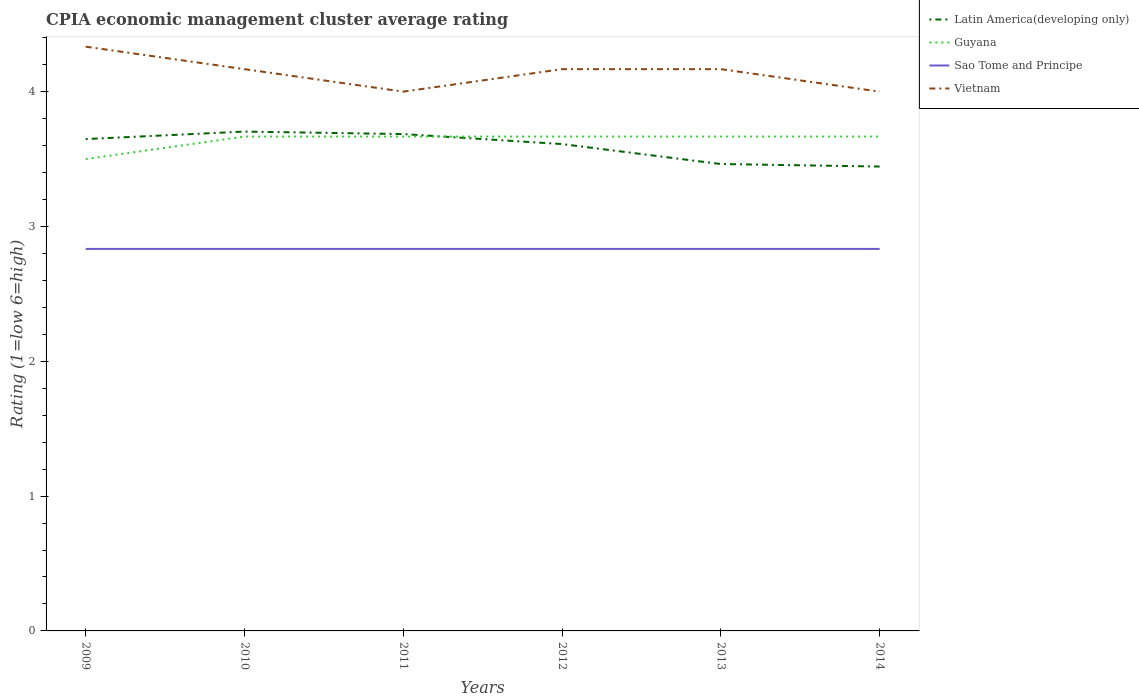What is the total CPIA rating in Guyana in the graph?
Your response must be concise. -3.333333329802457e-6. What is the difference between the highest and the second highest CPIA rating in Latin America(developing only)?
Ensure brevity in your answer.  0.26. What is the difference between the highest and the lowest CPIA rating in Vietnam?
Offer a very short reply. 4. Is the CPIA rating in Vietnam strictly greater than the CPIA rating in Sao Tome and Principe over the years?
Provide a succinct answer. No. How many years are there in the graph?
Your answer should be compact. 6. Does the graph contain any zero values?
Your answer should be compact. No. What is the title of the graph?
Provide a short and direct response. CPIA economic management cluster average rating. Does "China" appear as one of the legend labels in the graph?
Provide a short and direct response. No. What is the label or title of the X-axis?
Give a very brief answer. Years. What is the Rating (1=low 6=high) of Latin America(developing only) in 2009?
Your answer should be compact. 3.65. What is the Rating (1=low 6=high) in Sao Tome and Principe in 2009?
Offer a very short reply. 2.83. What is the Rating (1=low 6=high) of Vietnam in 2009?
Provide a succinct answer. 4.33. What is the Rating (1=low 6=high) in Latin America(developing only) in 2010?
Keep it short and to the point. 3.7. What is the Rating (1=low 6=high) of Guyana in 2010?
Offer a very short reply. 3.67. What is the Rating (1=low 6=high) in Sao Tome and Principe in 2010?
Offer a terse response. 2.83. What is the Rating (1=low 6=high) in Vietnam in 2010?
Provide a succinct answer. 4.17. What is the Rating (1=low 6=high) of Latin America(developing only) in 2011?
Provide a succinct answer. 3.69. What is the Rating (1=low 6=high) in Guyana in 2011?
Your response must be concise. 3.67. What is the Rating (1=low 6=high) in Sao Tome and Principe in 2011?
Make the answer very short. 2.83. What is the Rating (1=low 6=high) in Vietnam in 2011?
Make the answer very short. 4. What is the Rating (1=low 6=high) in Latin America(developing only) in 2012?
Ensure brevity in your answer.  3.61. What is the Rating (1=low 6=high) of Guyana in 2012?
Offer a very short reply. 3.67. What is the Rating (1=low 6=high) of Sao Tome and Principe in 2012?
Offer a very short reply. 2.83. What is the Rating (1=low 6=high) in Vietnam in 2012?
Offer a terse response. 4.17. What is the Rating (1=low 6=high) in Latin America(developing only) in 2013?
Offer a very short reply. 3.46. What is the Rating (1=low 6=high) of Guyana in 2013?
Offer a terse response. 3.67. What is the Rating (1=low 6=high) in Sao Tome and Principe in 2013?
Your response must be concise. 2.83. What is the Rating (1=low 6=high) in Vietnam in 2013?
Ensure brevity in your answer.  4.17. What is the Rating (1=low 6=high) of Latin America(developing only) in 2014?
Your response must be concise. 3.44. What is the Rating (1=low 6=high) in Guyana in 2014?
Keep it short and to the point. 3.67. What is the Rating (1=low 6=high) of Sao Tome and Principe in 2014?
Ensure brevity in your answer.  2.83. Across all years, what is the maximum Rating (1=low 6=high) of Latin America(developing only)?
Give a very brief answer. 3.7. Across all years, what is the maximum Rating (1=low 6=high) in Guyana?
Keep it short and to the point. 3.67. Across all years, what is the maximum Rating (1=low 6=high) of Sao Tome and Principe?
Provide a succinct answer. 2.83. Across all years, what is the maximum Rating (1=low 6=high) of Vietnam?
Your answer should be compact. 4.33. Across all years, what is the minimum Rating (1=low 6=high) in Latin America(developing only)?
Keep it short and to the point. 3.44. Across all years, what is the minimum Rating (1=low 6=high) of Guyana?
Your response must be concise. 3.5. Across all years, what is the minimum Rating (1=low 6=high) in Sao Tome and Principe?
Provide a succinct answer. 2.83. Across all years, what is the minimum Rating (1=low 6=high) of Vietnam?
Keep it short and to the point. 4. What is the total Rating (1=low 6=high) of Latin America(developing only) in the graph?
Make the answer very short. 21.56. What is the total Rating (1=low 6=high) in Guyana in the graph?
Offer a very short reply. 21.83. What is the total Rating (1=low 6=high) in Sao Tome and Principe in the graph?
Offer a terse response. 17. What is the total Rating (1=low 6=high) in Vietnam in the graph?
Give a very brief answer. 24.83. What is the difference between the Rating (1=low 6=high) in Latin America(developing only) in 2009 and that in 2010?
Offer a very short reply. -0.06. What is the difference between the Rating (1=low 6=high) in Latin America(developing only) in 2009 and that in 2011?
Provide a short and direct response. -0.04. What is the difference between the Rating (1=low 6=high) in Vietnam in 2009 and that in 2011?
Keep it short and to the point. 0.33. What is the difference between the Rating (1=low 6=high) of Latin America(developing only) in 2009 and that in 2012?
Your answer should be compact. 0.04. What is the difference between the Rating (1=low 6=high) of Sao Tome and Principe in 2009 and that in 2012?
Ensure brevity in your answer.  0. What is the difference between the Rating (1=low 6=high) in Vietnam in 2009 and that in 2012?
Provide a short and direct response. 0.17. What is the difference between the Rating (1=low 6=high) in Latin America(developing only) in 2009 and that in 2013?
Give a very brief answer. 0.19. What is the difference between the Rating (1=low 6=high) in Sao Tome and Principe in 2009 and that in 2013?
Make the answer very short. 0. What is the difference between the Rating (1=low 6=high) in Vietnam in 2009 and that in 2013?
Keep it short and to the point. 0.17. What is the difference between the Rating (1=low 6=high) of Latin America(developing only) in 2009 and that in 2014?
Provide a short and direct response. 0.2. What is the difference between the Rating (1=low 6=high) in Sao Tome and Principe in 2009 and that in 2014?
Provide a short and direct response. 0. What is the difference between the Rating (1=low 6=high) in Vietnam in 2009 and that in 2014?
Offer a terse response. 0.33. What is the difference between the Rating (1=low 6=high) of Latin America(developing only) in 2010 and that in 2011?
Give a very brief answer. 0.02. What is the difference between the Rating (1=low 6=high) in Latin America(developing only) in 2010 and that in 2012?
Make the answer very short. 0.09. What is the difference between the Rating (1=low 6=high) of Latin America(developing only) in 2010 and that in 2013?
Make the answer very short. 0.24. What is the difference between the Rating (1=low 6=high) of Guyana in 2010 and that in 2013?
Ensure brevity in your answer.  0. What is the difference between the Rating (1=low 6=high) in Latin America(developing only) in 2010 and that in 2014?
Offer a terse response. 0.26. What is the difference between the Rating (1=low 6=high) in Sao Tome and Principe in 2010 and that in 2014?
Make the answer very short. 0. What is the difference between the Rating (1=low 6=high) of Vietnam in 2010 and that in 2014?
Offer a very short reply. 0.17. What is the difference between the Rating (1=low 6=high) in Latin America(developing only) in 2011 and that in 2012?
Keep it short and to the point. 0.07. What is the difference between the Rating (1=low 6=high) in Guyana in 2011 and that in 2012?
Provide a short and direct response. 0. What is the difference between the Rating (1=low 6=high) of Latin America(developing only) in 2011 and that in 2013?
Give a very brief answer. 0.22. What is the difference between the Rating (1=low 6=high) of Sao Tome and Principe in 2011 and that in 2013?
Keep it short and to the point. 0. What is the difference between the Rating (1=low 6=high) of Vietnam in 2011 and that in 2013?
Offer a very short reply. -0.17. What is the difference between the Rating (1=low 6=high) of Latin America(developing only) in 2011 and that in 2014?
Give a very brief answer. 0.24. What is the difference between the Rating (1=low 6=high) in Guyana in 2011 and that in 2014?
Keep it short and to the point. -0. What is the difference between the Rating (1=low 6=high) of Latin America(developing only) in 2012 and that in 2013?
Give a very brief answer. 0.15. What is the difference between the Rating (1=low 6=high) of Guyana in 2012 and that in 2013?
Your answer should be very brief. 0. What is the difference between the Rating (1=low 6=high) in Vietnam in 2012 and that in 2013?
Your answer should be compact. 0. What is the difference between the Rating (1=low 6=high) in Guyana in 2012 and that in 2014?
Offer a terse response. -0. What is the difference between the Rating (1=low 6=high) in Latin America(developing only) in 2013 and that in 2014?
Give a very brief answer. 0.02. What is the difference between the Rating (1=low 6=high) in Vietnam in 2013 and that in 2014?
Provide a short and direct response. 0.17. What is the difference between the Rating (1=low 6=high) of Latin America(developing only) in 2009 and the Rating (1=low 6=high) of Guyana in 2010?
Your answer should be very brief. -0.02. What is the difference between the Rating (1=low 6=high) in Latin America(developing only) in 2009 and the Rating (1=low 6=high) in Sao Tome and Principe in 2010?
Your answer should be very brief. 0.81. What is the difference between the Rating (1=low 6=high) in Latin America(developing only) in 2009 and the Rating (1=low 6=high) in Vietnam in 2010?
Give a very brief answer. -0.52. What is the difference between the Rating (1=low 6=high) of Sao Tome and Principe in 2009 and the Rating (1=low 6=high) of Vietnam in 2010?
Make the answer very short. -1.33. What is the difference between the Rating (1=low 6=high) in Latin America(developing only) in 2009 and the Rating (1=low 6=high) in Guyana in 2011?
Keep it short and to the point. -0.02. What is the difference between the Rating (1=low 6=high) of Latin America(developing only) in 2009 and the Rating (1=low 6=high) of Sao Tome and Principe in 2011?
Your response must be concise. 0.81. What is the difference between the Rating (1=low 6=high) of Latin America(developing only) in 2009 and the Rating (1=low 6=high) of Vietnam in 2011?
Offer a terse response. -0.35. What is the difference between the Rating (1=low 6=high) in Sao Tome and Principe in 2009 and the Rating (1=low 6=high) in Vietnam in 2011?
Offer a terse response. -1.17. What is the difference between the Rating (1=low 6=high) of Latin America(developing only) in 2009 and the Rating (1=low 6=high) of Guyana in 2012?
Offer a terse response. -0.02. What is the difference between the Rating (1=low 6=high) in Latin America(developing only) in 2009 and the Rating (1=low 6=high) in Sao Tome and Principe in 2012?
Keep it short and to the point. 0.81. What is the difference between the Rating (1=low 6=high) of Latin America(developing only) in 2009 and the Rating (1=low 6=high) of Vietnam in 2012?
Give a very brief answer. -0.52. What is the difference between the Rating (1=low 6=high) of Guyana in 2009 and the Rating (1=low 6=high) of Sao Tome and Principe in 2012?
Provide a short and direct response. 0.67. What is the difference between the Rating (1=low 6=high) in Sao Tome and Principe in 2009 and the Rating (1=low 6=high) in Vietnam in 2012?
Your answer should be compact. -1.33. What is the difference between the Rating (1=low 6=high) of Latin America(developing only) in 2009 and the Rating (1=low 6=high) of Guyana in 2013?
Keep it short and to the point. -0.02. What is the difference between the Rating (1=low 6=high) of Latin America(developing only) in 2009 and the Rating (1=low 6=high) of Sao Tome and Principe in 2013?
Your answer should be very brief. 0.81. What is the difference between the Rating (1=low 6=high) of Latin America(developing only) in 2009 and the Rating (1=low 6=high) of Vietnam in 2013?
Offer a terse response. -0.52. What is the difference between the Rating (1=low 6=high) of Guyana in 2009 and the Rating (1=low 6=high) of Vietnam in 2013?
Offer a terse response. -0.67. What is the difference between the Rating (1=low 6=high) in Sao Tome and Principe in 2009 and the Rating (1=low 6=high) in Vietnam in 2013?
Offer a terse response. -1.33. What is the difference between the Rating (1=low 6=high) of Latin America(developing only) in 2009 and the Rating (1=low 6=high) of Guyana in 2014?
Give a very brief answer. -0.02. What is the difference between the Rating (1=low 6=high) of Latin America(developing only) in 2009 and the Rating (1=low 6=high) of Sao Tome and Principe in 2014?
Make the answer very short. 0.81. What is the difference between the Rating (1=low 6=high) in Latin America(developing only) in 2009 and the Rating (1=low 6=high) in Vietnam in 2014?
Offer a very short reply. -0.35. What is the difference between the Rating (1=low 6=high) of Guyana in 2009 and the Rating (1=low 6=high) of Sao Tome and Principe in 2014?
Your response must be concise. 0.67. What is the difference between the Rating (1=low 6=high) in Sao Tome and Principe in 2009 and the Rating (1=low 6=high) in Vietnam in 2014?
Ensure brevity in your answer.  -1.17. What is the difference between the Rating (1=low 6=high) in Latin America(developing only) in 2010 and the Rating (1=low 6=high) in Guyana in 2011?
Give a very brief answer. 0.04. What is the difference between the Rating (1=low 6=high) in Latin America(developing only) in 2010 and the Rating (1=low 6=high) in Sao Tome and Principe in 2011?
Offer a terse response. 0.87. What is the difference between the Rating (1=low 6=high) in Latin America(developing only) in 2010 and the Rating (1=low 6=high) in Vietnam in 2011?
Ensure brevity in your answer.  -0.3. What is the difference between the Rating (1=low 6=high) in Guyana in 2010 and the Rating (1=low 6=high) in Sao Tome and Principe in 2011?
Give a very brief answer. 0.83. What is the difference between the Rating (1=low 6=high) in Guyana in 2010 and the Rating (1=low 6=high) in Vietnam in 2011?
Your response must be concise. -0.33. What is the difference between the Rating (1=low 6=high) of Sao Tome and Principe in 2010 and the Rating (1=low 6=high) of Vietnam in 2011?
Give a very brief answer. -1.17. What is the difference between the Rating (1=low 6=high) in Latin America(developing only) in 2010 and the Rating (1=low 6=high) in Guyana in 2012?
Your answer should be compact. 0.04. What is the difference between the Rating (1=low 6=high) of Latin America(developing only) in 2010 and the Rating (1=low 6=high) of Sao Tome and Principe in 2012?
Offer a very short reply. 0.87. What is the difference between the Rating (1=low 6=high) in Latin America(developing only) in 2010 and the Rating (1=low 6=high) in Vietnam in 2012?
Make the answer very short. -0.46. What is the difference between the Rating (1=low 6=high) of Sao Tome and Principe in 2010 and the Rating (1=low 6=high) of Vietnam in 2012?
Your answer should be compact. -1.33. What is the difference between the Rating (1=low 6=high) in Latin America(developing only) in 2010 and the Rating (1=low 6=high) in Guyana in 2013?
Your answer should be very brief. 0.04. What is the difference between the Rating (1=low 6=high) in Latin America(developing only) in 2010 and the Rating (1=low 6=high) in Sao Tome and Principe in 2013?
Your answer should be very brief. 0.87. What is the difference between the Rating (1=low 6=high) of Latin America(developing only) in 2010 and the Rating (1=low 6=high) of Vietnam in 2013?
Provide a succinct answer. -0.46. What is the difference between the Rating (1=low 6=high) in Guyana in 2010 and the Rating (1=low 6=high) in Sao Tome and Principe in 2013?
Offer a terse response. 0.83. What is the difference between the Rating (1=low 6=high) in Guyana in 2010 and the Rating (1=low 6=high) in Vietnam in 2013?
Keep it short and to the point. -0.5. What is the difference between the Rating (1=low 6=high) of Sao Tome and Principe in 2010 and the Rating (1=low 6=high) of Vietnam in 2013?
Your answer should be compact. -1.33. What is the difference between the Rating (1=low 6=high) in Latin America(developing only) in 2010 and the Rating (1=low 6=high) in Guyana in 2014?
Provide a short and direct response. 0.04. What is the difference between the Rating (1=low 6=high) in Latin America(developing only) in 2010 and the Rating (1=low 6=high) in Sao Tome and Principe in 2014?
Provide a succinct answer. 0.87. What is the difference between the Rating (1=low 6=high) of Latin America(developing only) in 2010 and the Rating (1=low 6=high) of Vietnam in 2014?
Provide a succinct answer. -0.3. What is the difference between the Rating (1=low 6=high) of Guyana in 2010 and the Rating (1=low 6=high) of Sao Tome and Principe in 2014?
Your answer should be very brief. 0.83. What is the difference between the Rating (1=low 6=high) of Sao Tome and Principe in 2010 and the Rating (1=low 6=high) of Vietnam in 2014?
Ensure brevity in your answer.  -1.17. What is the difference between the Rating (1=low 6=high) of Latin America(developing only) in 2011 and the Rating (1=low 6=high) of Guyana in 2012?
Keep it short and to the point. 0.02. What is the difference between the Rating (1=low 6=high) in Latin America(developing only) in 2011 and the Rating (1=low 6=high) in Sao Tome and Principe in 2012?
Give a very brief answer. 0.85. What is the difference between the Rating (1=low 6=high) in Latin America(developing only) in 2011 and the Rating (1=low 6=high) in Vietnam in 2012?
Your response must be concise. -0.48. What is the difference between the Rating (1=low 6=high) of Guyana in 2011 and the Rating (1=low 6=high) of Sao Tome and Principe in 2012?
Provide a succinct answer. 0.83. What is the difference between the Rating (1=low 6=high) in Guyana in 2011 and the Rating (1=low 6=high) in Vietnam in 2012?
Keep it short and to the point. -0.5. What is the difference between the Rating (1=low 6=high) of Sao Tome and Principe in 2011 and the Rating (1=low 6=high) of Vietnam in 2012?
Offer a terse response. -1.33. What is the difference between the Rating (1=low 6=high) in Latin America(developing only) in 2011 and the Rating (1=low 6=high) in Guyana in 2013?
Provide a succinct answer. 0.02. What is the difference between the Rating (1=low 6=high) of Latin America(developing only) in 2011 and the Rating (1=low 6=high) of Sao Tome and Principe in 2013?
Keep it short and to the point. 0.85. What is the difference between the Rating (1=low 6=high) in Latin America(developing only) in 2011 and the Rating (1=low 6=high) in Vietnam in 2013?
Keep it short and to the point. -0.48. What is the difference between the Rating (1=low 6=high) of Guyana in 2011 and the Rating (1=low 6=high) of Vietnam in 2013?
Your answer should be compact. -0.5. What is the difference between the Rating (1=low 6=high) in Sao Tome and Principe in 2011 and the Rating (1=low 6=high) in Vietnam in 2013?
Ensure brevity in your answer.  -1.33. What is the difference between the Rating (1=low 6=high) of Latin America(developing only) in 2011 and the Rating (1=low 6=high) of Guyana in 2014?
Provide a succinct answer. 0.02. What is the difference between the Rating (1=low 6=high) of Latin America(developing only) in 2011 and the Rating (1=low 6=high) of Sao Tome and Principe in 2014?
Provide a succinct answer. 0.85. What is the difference between the Rating (1=low 6=high) in Latin America(developing only) in 2011 and the Rating (1=low 6=high) in Vietnam in 2014?
Ensure brevity in your answer.  -0.31. What is the difference between the Rating (1=low 6=high) of Guyana in 2011 and the Rating (1=low 6=high) of Sao Tome and Principe in 2014?
Offer a very short reply. 0.83. What is the difference between the Rating (1=low 6=high) in Sao Tome and Principe in 2011 and the Rating (1=low 6=high) in Vietnam in 2014?
Offer a very short reply. -1.17. What is the difference between the Rating (1=low 6=high) of Latin America(developing only) in 2012 and the Rating (1=low 6=high) of Guyana in 2013?
Your answer should be compact. -0.06. What is the difference between the Rating (1=low 6=high) of Latin America(developing only) in 2012 and the Rating (1=low 6=high) of Vietnam in 2013?
Provide a succinct answer. -0.56. What is the difference between the Rating (1=low 6=high) in Guyana in 2012 and the Rating (1=low 6=high) in Vietnam in 2013?
Give a very brief answer. -0.5. What is the difference between the Rating (1=low 6=high) in Sao Tome and Principe in 2012 and the Rating (1=low 6=high) in Vietnam in 2013?
Your response must be concise. -1.33. What is the difference between the Rating (1=low 6=high) of Latin America(developing only) in 2012 and the Rating (1=low 6=high) of Guyana in 2014?
Make the answer very short. -0.06. What is the difference between the Rating (1=low 6=high) in Latin America(developing only) in 2012 and the Rating (1=low 6=high) in Vietnam in 2014?
Keep it short and to the point. -0.39. What is the difference between the Rating (1=low 6=high) of Guyana in 2012 and the Rating (1=low 6=high) of Sao Tome and Principe in 2014?
Give a very brief answer. 0.83. What is the difference between the Rating (1=low 6=high) of Sao Tome and Principe in 2012 and the Rating (1=low 6=high) of Vietnam in 2014?
Your response must be concise. -1.17. What is the difference between the Rating (1=low 6=high) of Latin America(developing only) in 2013 and the Rating (1=low 6=high) of Guyana in 2014?
Provide a short and direct response. -0.2. What is the difference between the Rating (1=low 6=high) of Latin America(developing only) in 2013 and the Rating (1=low 6=high) of Sao Tome and Principe in 2014?
Make the answer very short. 0.63. What is the difference between the Rating (1=low 6=high) in Latin America(developing only) in 2013 and the Rating (1=low 6=high) in Vietnam in 2014?
Give a very brief answer. -0.54. What is the difference between the Rating (1=low 6=high) of Sao Tome and Principe in 2013 and the Rating (1=low 6=high) of Vietnam in 2014?
Your answer should be very brief. -1.17. What is the average Rating (1=low 6=high) of Latin America(developing only) per year?
Ensure brevity in your answer.  3.59. What is the average Rating (1=low 6=high) in Guyana per year?
Your answer should be very brief. 3.64. What is the average Rating (1=low 6=high) in Sao Tome and Principe per year?
Offer a terse response. 2.83. What is the average Rating (1=low 6=high) in Vietnam per year?
Provide a succinct answer. 4.14. In the year 2009, what is the difference between the Rating (1=low 6=high) of Latin America(developing only) and Rating (1=low 6=high) of Guyana?
Your answer should be very brief. 0.15. In the year 2009, what is the difference between the Rating (1=low 6=high) in Latin America(developing only) and Rating (1=low 6=high) in Sao Tome and Principe?
Your answer should be compact. 0.81. In the year 2009, what is the difference between the Rating (1=low 6=high) in Latin America(developing only) and Rating (1=low 6=high) in Vietnam?
Provide a short and direct response. -0.69. In the year 2009, what is the difference between the Rating (1=low 6=high) in Guyana and Rating (1=low 6=high) in Vietnam?
Ensure brevity in your answer.  -0.83. In the year 2010, what is the difference between the Rating (1=low 6=high) in Latin America(developing only) and Rating (1=low 6=high) in Guyana?
Offer a terse response. 0.04. In the year 2010, what is the difference between the Rating (1=low 6=high) in Latin America(developing only) and Rating (1=low 6=high) in Sao Tome and Principe?
Your answer should be very brief. 0.87. In the year 2010, what is the difference between the Rating (1=low 6=high) of Latin America(developing only) and Rating (1=low 6=high) of Vietnam?
Provide a short and direct response. -0.46. In the year 2010, what is the difference between the Rating (1=low 6=high) of Guyana and Rating (1=low 6=high) of Vietnam?
Make the answer very short. -0.5. In the year 2010, what is the difference between the Rating (1=low 6=high) of Sao Tome and Principe and Rating (1=low 6=high) of Vietnam?
Offer a very short reply. -1.33. In the year 2011, what is the difference between the Rating (1=low 6=high) of Latin America(developing only) and Rating (1=low 6=high) of Guyana?
Your answer should be very brief. 0.02. In the year 2011, what is the difference between the Rating (1=low 6=high) in Latin America(developing only) and Rating (1=low 6=high) in Sao Tome and Principe?
Give a very brief answer. 0.85. In the year 2011, what is the difference between the Rating (1=low 6=high) of Latin America(developing only) and Rating (1=low 6=high) of Vietnam?
Ensure brevity in your answer.  -0.31. In the year 2011, what is the difference between the Rating (1=low 6=high) of Guyana and Rating (1=low 6=high) of Sao Tome and Principe?
Your answer should be very brief. 0.83. In the year 2011, what is the difference between the Rating (1=low 6=high) of Guyana and Rating (1=low 6=high) of Vietnam?
Offer a very short reply. -0.33. In the year 2011, what is the difference between the Rating (1=low 6=high) in Sao Tome and Principe and Rating (1=low 6=high) in Vietnam?
Ensure brevity in your answer.  -1.17. In the year 2012, what is the difference between the Rating (1=low 6=high) in Latin America(developing only) and Rating (1=low 6=high) in Guyana?
Your response must be concise. -0.06. In the year 2012, what is the difference between the Rating (1=low 6=high) in Latin America(developing only) and Rating (1=low 6=high) in Vietnam?
Ensure brevity in your answer.  -0.56. In the year 2012, what is the difference between the Rating (1=low 6=high) in Guyana and Rating (1=low 6=high) in Sao Tome and Principe?
Ensure brevity in your answer.  0.83. In the year 2012, what is the difference between the Rating (1=low 6=high) in Sao Tome and Principe and Rating (1=low 6=high) in Vietnam?
Keep it short and to the point. -1.33. In the year 2013, what is the difference between the Rating (1=low 6=high) in Latin America(developing only) and Rating (1=low 6=high) in Guyana?
Offer a terse response. -0.2. In the year 2013, what is the difference between the Rating (1=low 6=high) in Latin America(developing only) and Rating (1=low 6=high) in Sao Tome and Principe?
Your answer should be very brief. 0.63. In the year 2013, what is the difference between the Rating (1=low 6=high) of Latin America(developing only) and Rating (1=low 6=high) of Vietnam?
Offer a very short reply. -0.7. In the year 2013, what is the difference between the Rating (1=low 6=high) of Guyana and Rating (1=low 6=high) of Vietnam?
Provide a succinct answer. -0.5. In the year 2013, what is the difference between the Rating (1=low 6=high) of Sao Tome and Principe and Rating (1=low 6=high) of Vietnam?
Your response must be concise. -1.33. In the year 2014, what is the difference between the Rating (1=low 6=high) in Latin America(developing only) and Rating (1=low 6=high) in Guyana?
Provide a succinct answer. -0.22. In the year 2014, what is the difference between the Rating (1=low 6=high) of Latin America(developing only) and Rating (1=low 6=high) of Sao Tome and Principe?
Your answer should be compact. 0.61. In the year 2014, what is the difference between the Rating (1=low 6=high) in Latin America(developing only) and Rating (1=low 6=high) in Vietnam?
Provide a short and direct response. -0.56. In the year 2014, what is the difference between the Rating (1=low 6=high) of Sao Tome and Principe and Rating (1=low 6=high) of Vietnam?
Offer a terse response. -1.17. What is the ratio of the Rating (1=low 6=high) in Latin America(developing only) in 2009 to that in 2010?
Your answer should be compact. 0.98. What is the ratio of the Rating (1=low 6=high) of Guyana in 2009 to that in 2010?
Provide a short and direct response. 0.95. What is the ratio of the Rating (1=low 6=high) in Vietnam in 2009 to that in 2010?
Provide a succinct answer. 1.04. What is the ratio of the Rating (1=low 6=high) of Latin America(developing only) in 2009 to that in 2011?
Your response must be concise. 0.99. What is the ratio of the Rating (1=low 6=high) of Guyana in 2009 to that in 2011?
Offer a terse response. 0.95. What is the ratio of the Rating (1=low 6=high) of Sao Tome and Principe in 2009 to that in 2011?
Ensure brevity in your answer.  1. What is the ratio of the Rating (1=low 6=high) of Vietnam in 2009 to that in 2011?
Offer a very short reply. 1.08. What is the ratio of the Rating (1=low 6=high) in Latin America(developing only) in 2009 to that in 2012?
Your response must be concise. 1.01. What is the ratio of the Rating (1=low 6=high) of Guyana in 2009 to that in 2012?
Offer a terse response. 0.95. What is the ratio of the Rating (1=low 6=high) of Latin America(developing only) in 2009 to that in 2013?
Offer a terse response. 1.05. What is the ratio of the Rating (1=low 6=high) of Guyana in 2009 to that in 2013?
Your response must be concise. 0.95. What is the ratio of the Rating (1=low 6=high) of Sao Tome and Principe in 2009 to that in 2013?
Make the answer very short. 1. What is the ratio of the Rating (1=low 6=high) in Vietnam in 2009 to that in 2013?
Your answer should be very brief. 1.04. What is the ratio of the Rating (1=low 6=high) in Latin America(developing only) in 2009 to that in 2014?
Give a very brief answer. 1.06. What is the ratio of the Rating (1=low 6=high) of Guyana in 2009 to that in 2014?
Make the answer very short. 0.95. What is the ratio of the Rating (1=low 6=high) of Vietnam in 2009 to that in 2014?
Ensure brevity in your answer.  1.08. What is the ratio of the Rating (1=low 6=high) of Latin America(developing only) in 2010 to that in 2011?
Offer a terse response. 1. What is the ratio of the Rating (1=low 6=high) of Sao Tome and Principe in 2010 to that in 2011?
Make the answer very short. 1. What is the ratio of the Rating (1=low 6=high) of Vietnam in 2010 to that in 2011?
Offer a terse response. 1.04. What is the ratio of the Rating (1=low 6=high) of Latin America(developing only) in 2010 to that in 2012?
Offer a terse response. 1.03. What is the ratio of the Rating (1=low 6=high) of Sao Tome and Principe in 2010 to that in 2012?
Your answer should be very brief. 1. What is the ratio of the Rating (1=low 6=high) of Vietnam in 2010 to that in 2012?
Make the answer very short. 1. What is the ratio of the Rating (1=low 6=high) in Latin America(developing only) in 2010 to that in 2013?
Your answer should be compact. 1.07. What is the ratio of the Rating (1=low 6=high) of Sao Tome and Principe in 2010 to that in 2013?
Make the answer very short. 1. What is the ratio of the Rating (1=low 6=high) of Latin America(developing only) in 2010 to that in 2014?
Make the answer very short. 1.08. What is the ratio of the Rating (1=low 6=high) in Sao Tome and Principe in 2010 to that in 2014?
Make the answer very short. 1. What is the ratio of the Rating (1=low 6=high) of Vietnam in 2010 to that in 2014?
Ensure brevity in your answer.  1.04. What is the ratio of the Rating (1=low 6=high) of Latin America(developing only) in 2011 to that in 2012?
Your answer should be compact. 1.02. What is the ratio of the Rating (1=low 6=high) of Guyana in 2011 to that in 2012?
Provide a short and direct response. 1. What is the ratio of the Rating (1=low 6=high) of Sao Tome and Principe in 2011 to that in 2012?
Keep it short and to the point. 1. What is the ratio of the Rating (1=low 6=high) of Latin America(developing only) in 2011 to that in 2013?
Your answer should be compact. 1.06. What is the ratio of the Rating (1=low 6=high) in Latin America(developing only) in 2011 to that in 2014?
Your answer should be very brief. 1.07. What is the ratio of the Rating (1=low 6=high) of Sao Tome and Principe in 2011 to that in 2014?
Ensure brevity in your answer.  1. What is the ratio of the Rating (1=low 6=high) of Latin America(developing only) in 2012 to that in 2013?
Make the answer very short. 1.04. What is the ratio of the Rating (1=low 6=high) of Sao Tome and Principe in 2012 to that in 2013?
Offer a terse response. 1. What is the ratio of the Rating (1=low 6=high) of Latin America(developing only) in 2012 to that in 2014?
Give a very brief answer. 1.05. What is the ratio of the Rating (1=low 6=high) of Guyana in 2012 to that in 2014?
Your answer should be very brief. 1. What is the ratio of the Rating (1=low 6=high) of Vietnam in 2012 to that in 2014?
Give a very brief answer. 1.04. What is the ratio of the Rating (1=low 6=high) of Latin America(developing only) in 2013 to that in 2014?
Your response must be concise. 1.01. What is the ratio of the Rating (1=low 6=high) in Guyana in 2013 to that in 2014?
Give a very brief answer. 1. What is the ratio of the Rating (1=low 6=high) in Vietnam in 2013 to that in 2014?
Provide a short and direct response. 1.04. What is the difference between the highest and the second highest Rating (1=low 6=high) in Latin America(developing only)?
Your answer should be very brief. 0.02. What is the difference between the highest and the second highest Rating (1=low 6=high) in Guyana?
Give a very brief answer. 0. What is the difference between the highest and the second highest Rating (1=low 6=high) of Sao Tome and Principe?
Offer a very short reply. 0. What is the difference between the highest and the lowest Rating (1=low 6=high) of Latin America(developing only)?
Provide a succinct answer. 0.26. What is the difference between the highest and the lowest Rating (1=low 6=high) in Sao Tome and Principe?
Your response must be concise. 0. 